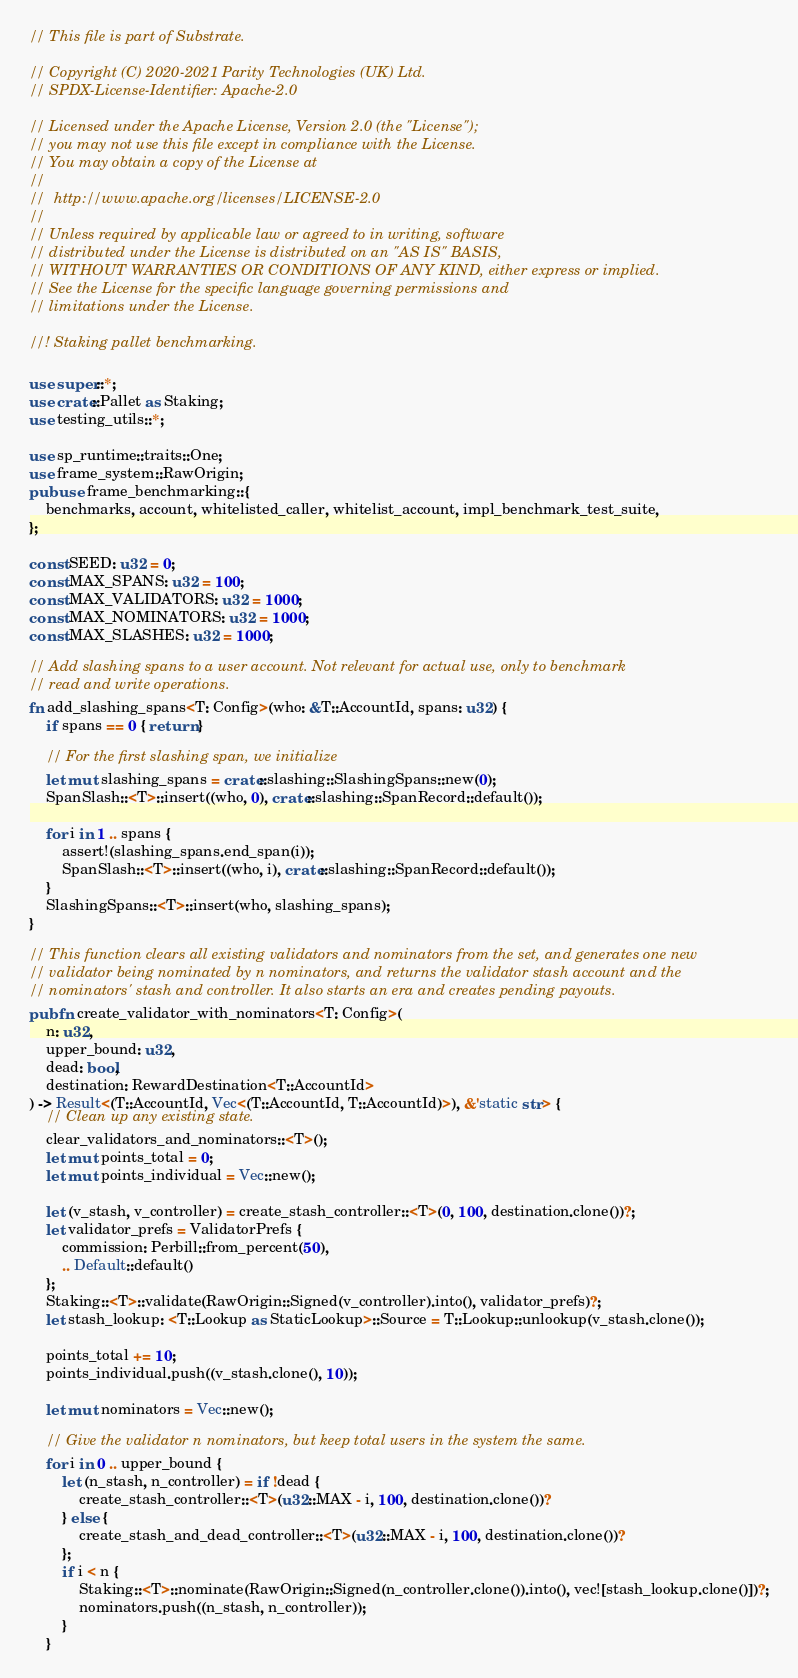Convert code to text. <code><loc_0><loc_0><loc_500><loc_500><_Rust_>// This file is part of Substrate.

// Copyright (C) 2020-2021 Parity Technologies (UK) Ltd.
// SPDX-License-Identifier: Apache-2.0

// Licensed under the Apache License, Version 2.0 (the "License");
// you may not use this file except in compliance with the License.
// You may obtain a copy of the License at
//
// 	http://www.apache.org/licenses/LICENSE-2.0
//
// Unless required by applicable law or agreed to in writing, software
// distributed under the License is distributed on an "AS IS" BASIS,
// WITHOUT WARRANTIES OR CONDITIONS OF ANY KIND, either express or implied.
// See the License for the specific language governing permissions and
// limitations under the License.

//! Staking pallet benchmarking.

use super::*;
use crate::Pallet as Staking;
use testing_utils::*;

use sp_runtime::traits::One;
use frame_system::RawOrigin;
pub use frame_benchmarking::{
	benchmarks, account, whitelisted_caller, whitelist_account, impl_benchmark_test_suite,
};

const SEED: u32 = 0;
const MAX_SPANS: u32 = 100;
const MAX_VALIDATORS: u32 = 1000;
const MAX_NOMINATORS: u32 = 1000;
const MAX_SLASHES: u32 = 1000;

// Add slashing spans to a user account. Not relevant for actual use, only to benchmark
// read and write operations.
fn add_slashing_spans<T: Config>(who: &T::AccountId, spans: u32) {
	if spans == 0 { return }

	// For the first slashing span, we initialize
	let mut slashing_spans = crate::slashing::SlashingSpans::new(0);
	SpanSlash::<T>::insert((who, 0), crate::slashing::SpanRecord::default());

	for i in 1 .. spans {
		assert!(slashing_spans.end_span(i));
		SpanSlash::<T>::insert((who, i), crate::slashing::SpanRecord::default());
	}
	SlashingSpans::<T>::insert(who, slashing_spans);
}

// This function clears all existing validators and nominators from the set, and generates one new
// validator being nominated by n nominators, and returns the validator stash account and the
// nominators' stash and controller. It also starts an era and creates pending payouts.
pub fn create_validator_with_nominators<T: Config>(
	n: u32,
	upper_bound: u32,
	dead: bool,
	destination: RewardDestination<T::AccountId>
) -> Result<(T::AccountId, Vec<(T::AccountId, T::AccountId)>), &'static str> {
	// Clean up any existing state.
	clear_validators_and_nominators::<T>();
	let mut points_total = 0;
	let mut points_individual = Vec::new();

	let (v_stash, v_controller) = create_stash_controller::<T>(0, 100, destination.clone())?;
	let validator_prefs = ValidatorPrefs {
		commission: Perbill::from_percent(50),
		.. Default::default()
	};
	Staking::<T>::validate(RawOrigin::Signed(v_controller).into(), validator_prefs)?;
	let stash_lookup: <T::Lookup as StaticLookup>::Source = T::Lookup::unlookup(v_stash.clone());

	points_total += 10;
	points_individual.push((v_stash.clone(), 10));

	let mut nominators = Vec::new();

	// Give the validator n nominators, but keep total users in the system the same.
	for i in 0 .. upper_bound {
		let (n_stash, n_controller) = if !dead {
			create_stash_controller::<T>(u32::MAX - i, 100, destination.clone())?
		} else {
			create_stash_and_dead_controller::<T>(u32::MAX - i, 100, destination.clone())?
		};
		if i < n {
			Staking::<T>::nominate(RawOrigin::Signed(n_controller.clone()).into(), vec![stash_lookup.clone()])?;
			nominators.push((n_stash, n_controller));
		}
	}
</code> 